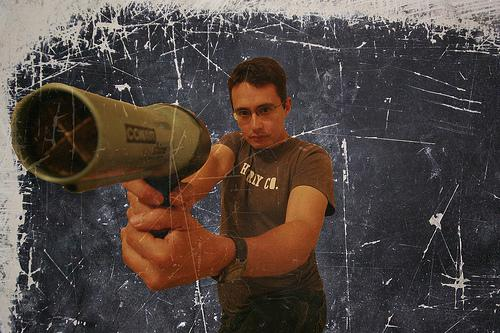Question: what is black?
Choices:
A. The cat.
B. The sky.
C. The car.
D. The wall.
Answer with the letter. Answer: D Question: what is on his wrist?
Choices:
A. Watch.
B. A band.
C. A tattoo.
D. A fly.
Answer with the letter. Answer: A 